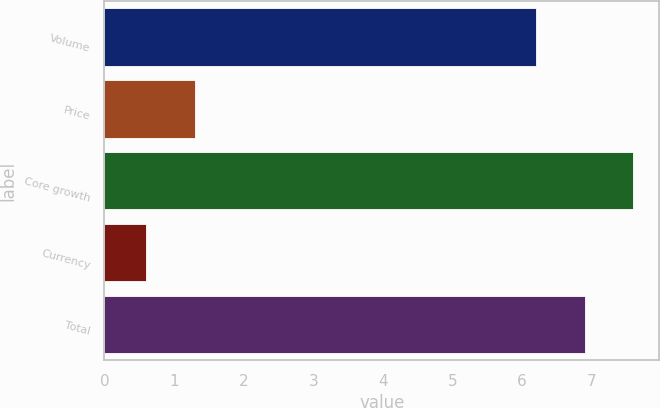Convert chart. <chart><loc_0><loc_0><loc_500><loc_500><bar_chart><fcel>Volume<fcel>Price<fcel>Core growth<fcel>Currency<fcel>Total<nl><fcel>6.2<fcel>1.3<fcel>7.59<fcel>0.6<fcel>6.9<nl></chart> 